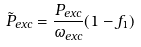<formula> <loc_0><loc_0><loc_500><loc_500>\tilde { P } _ { e x c } = { \frac { P _ { e x c } } { \omega _ { e x c } } } ( 1 - f _ { 1 } )</formula> 